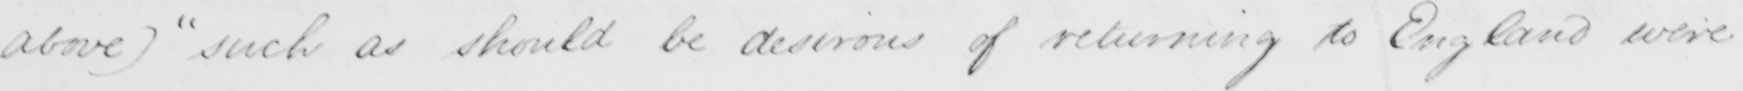Transcribe the text shown in this historical manuscript line. above )  such as should be desirous of returning to England were 